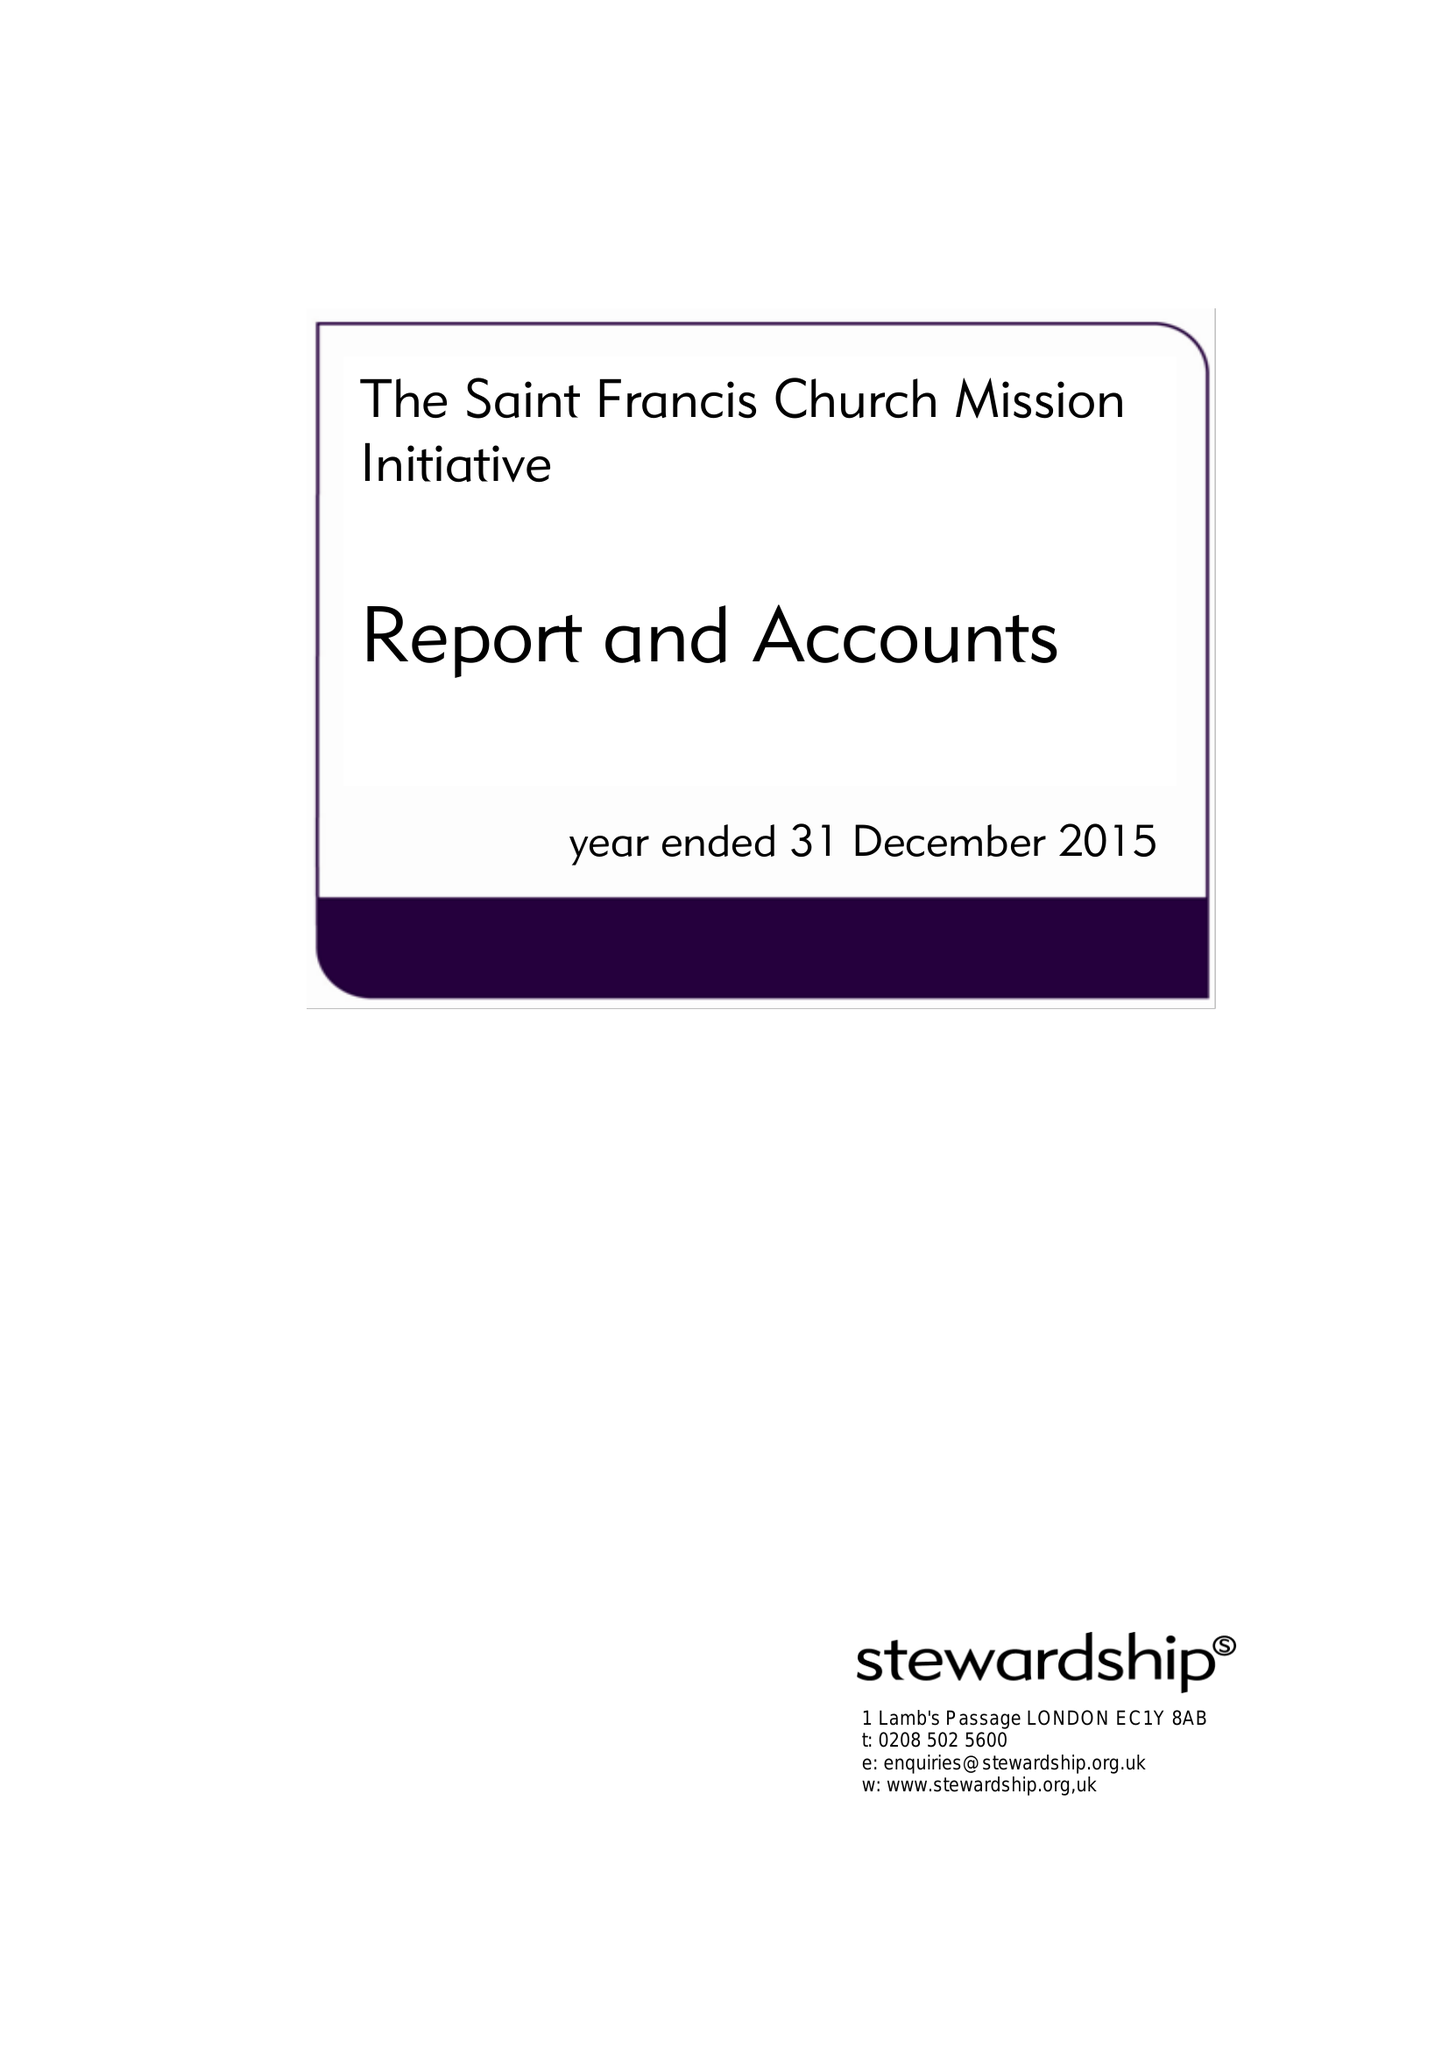What is the value for the charity_name?
Answer the question using a single word or phrase. The Saint Francis Church Mission Initiative 